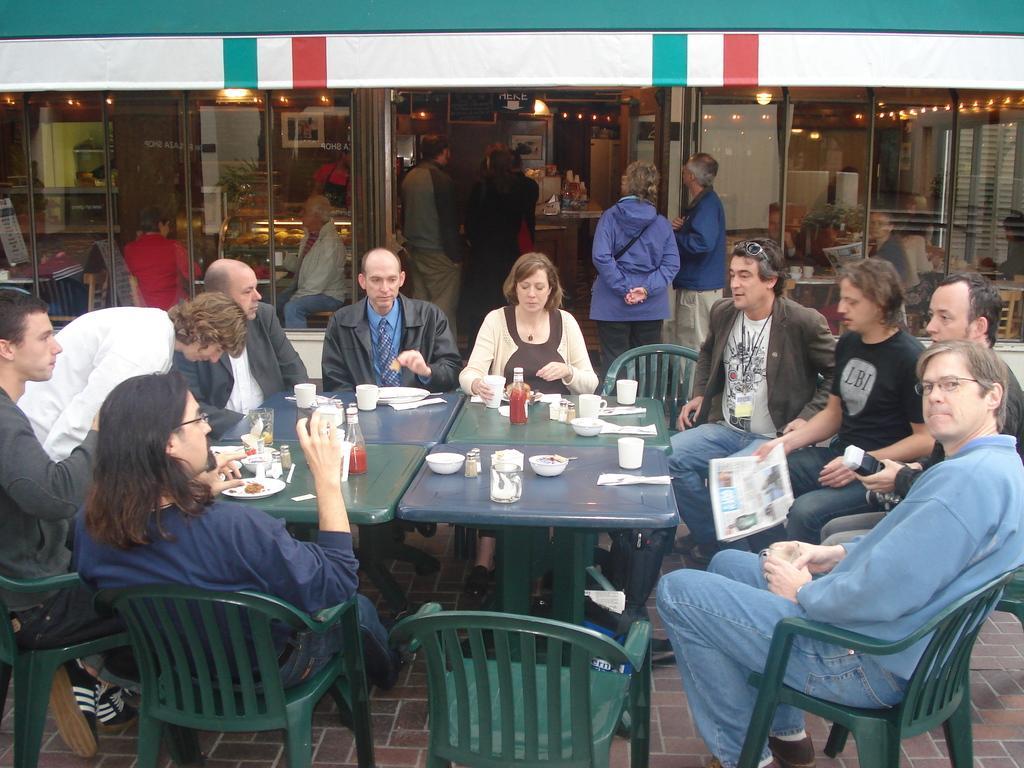Can you describe this image briefly? There are many people sitting on the chair. In front of them there is a table with bowls, cups, papers, bottle, tissues and a plate on it. And in the background there is a store. In front of the store there are some people standing. 